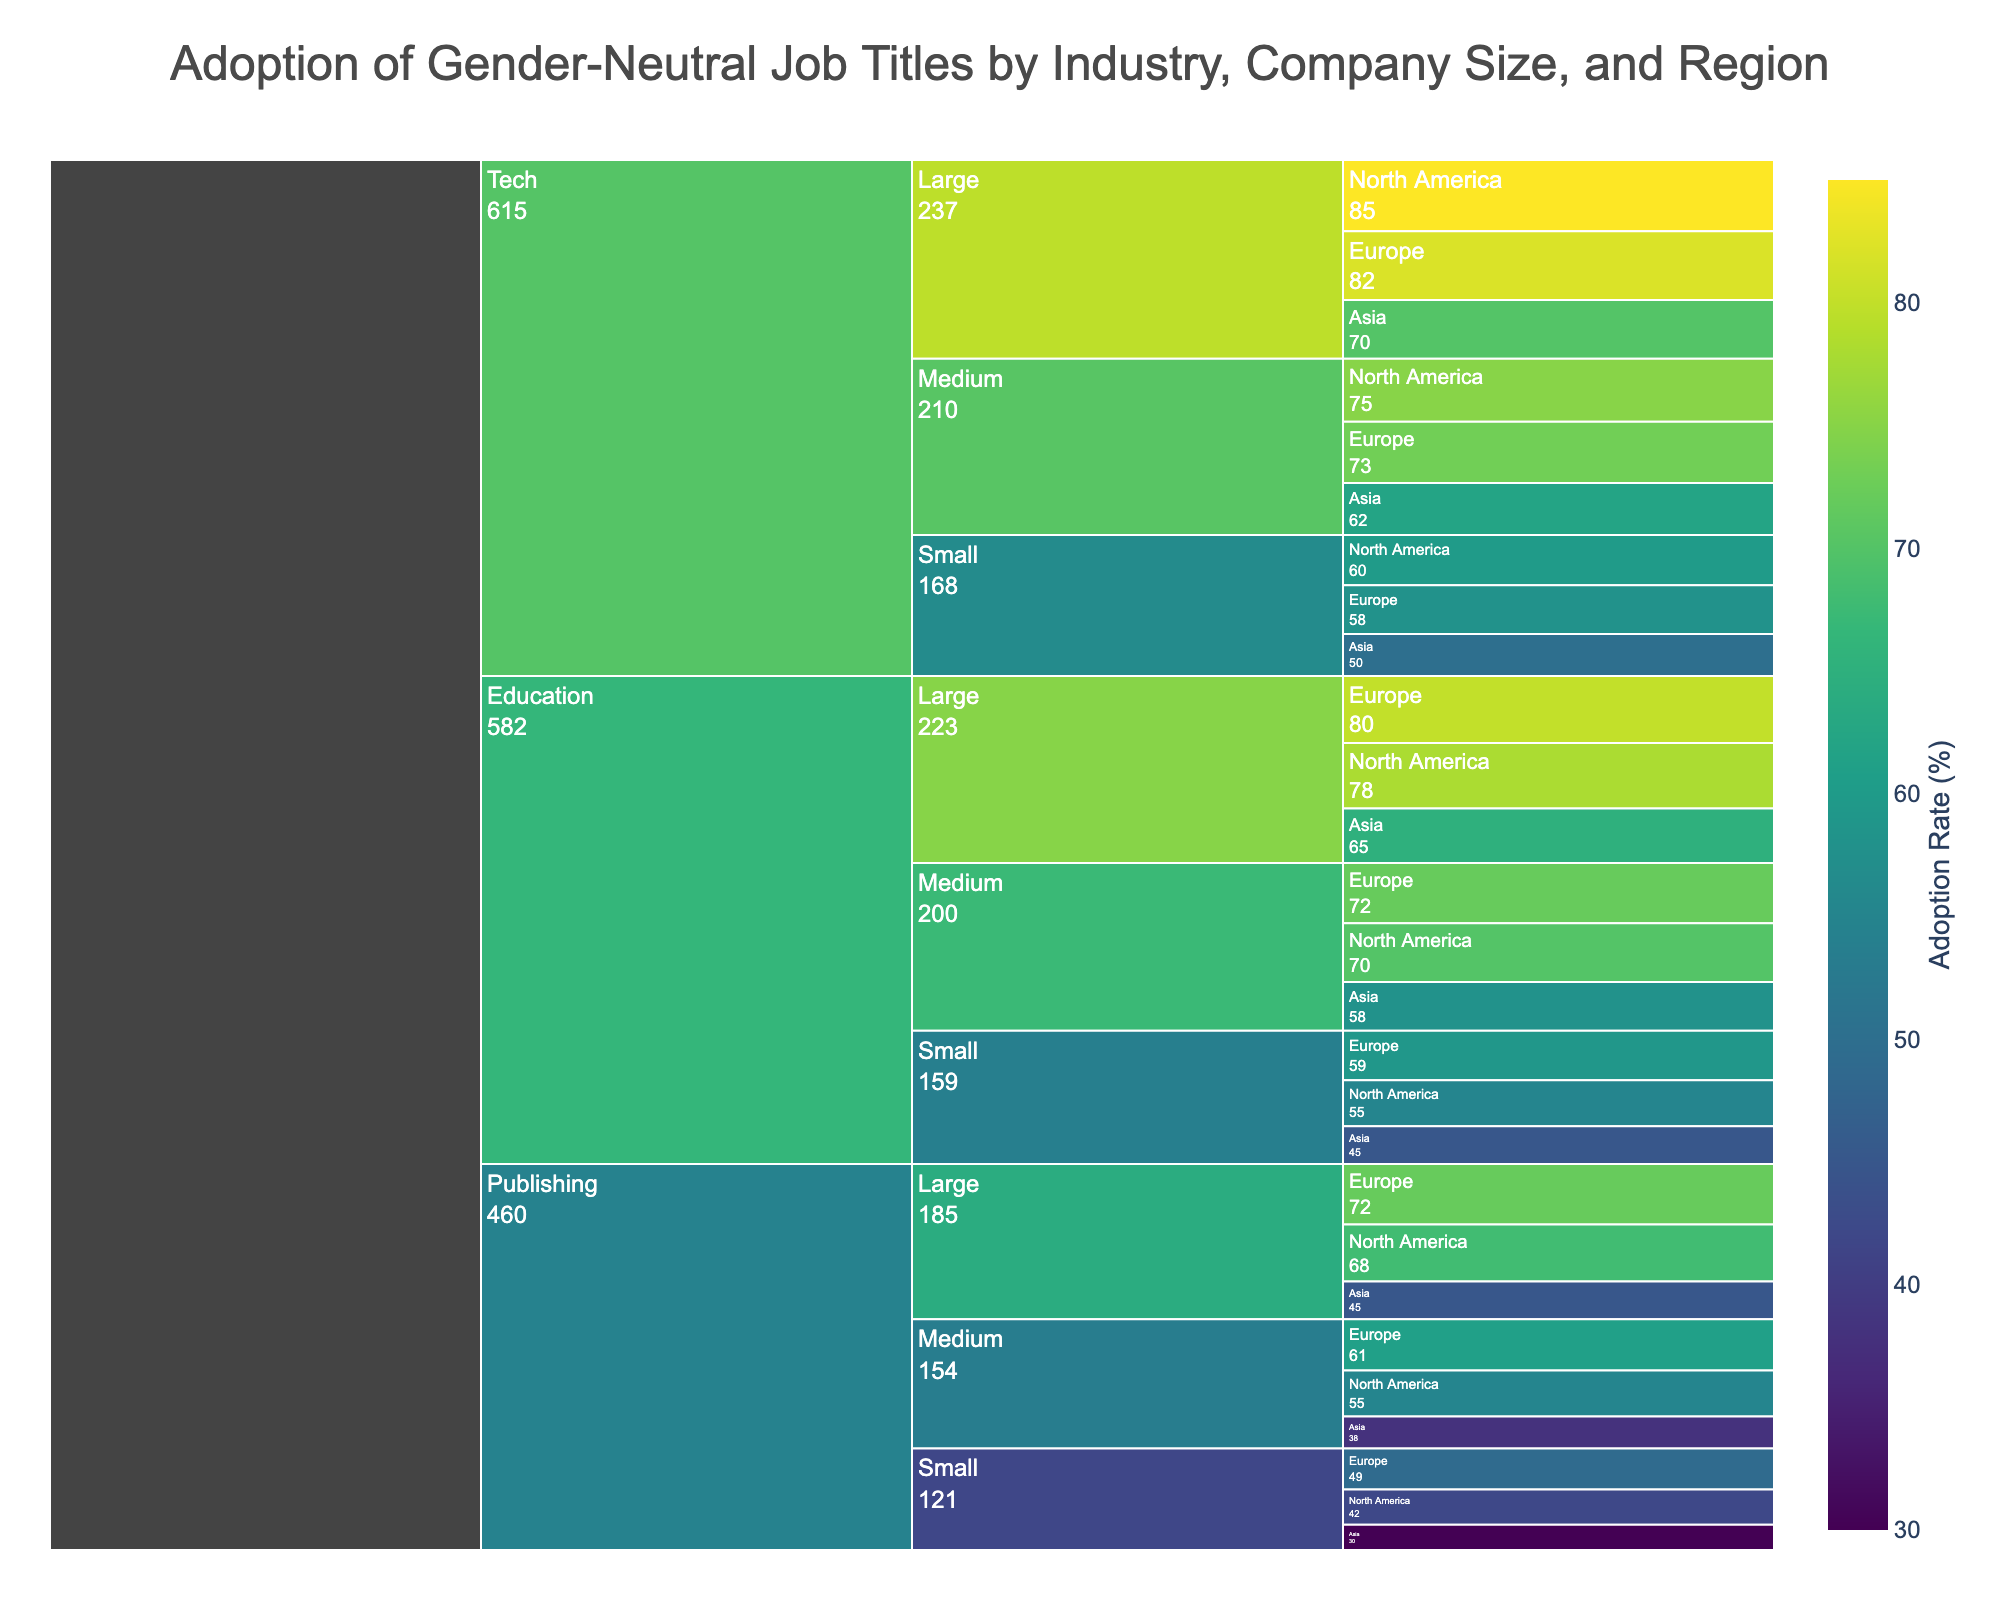What is the title of the figure? The title of the figure is displayed at the top of the Icicle Chart. It reads "Adoption of Gender-Neutral Job Titles by Industry, Company Size, and Region."
Answer: Adoption of Gender-Neutral Job Titles by Industry, Company Size, and Region Which industry has the highest adoption rate overall? To find the industry with the highest adoption rate, we need to compare the values given for different industries. Tech sector generally has higher adoption rates compared to Publishing and Education.
Answer: Tech What is the adoption rate for medium-sized tech companies in Asia? Locate the section for the Tech industry, then navigate to medium-sized companies and find the adoption rate for Asia.
Answer: 62% Which region shows the highest adoption rate for large publishing companies? In the Publishing industry section, look at large companies and compare the values for North America, Europe, and Asia. Europe has the highest adoption rate of 72%.
Answer: Europe What is the difference in adoption rates between small and large companies in the Education industry in North America? Find the adoption rates for small and large Educational companies in North America and subtract the smaller value from the larger one: 78% (large) - 55% (small).
Answer: 23% Which combination of industry, company size, and region has the lowest adoption rate? Scan the entire Icicle Chart to find the lowest adoption rate. Small Publishing companies in Asia have the lowest adoption rate of 30%.
Answer: Small Publishing companies in Asia How does the adoption rate compare between small-sized tech companies in North America and Europe? Compare the values for small tech companies in North America and Europe. North America has a value of 60%, while Europe has 58%, making North America's adoption rate slightly higher.
Answer: North America is higher by 2% What is the average adoption rate for medium-sized companies across all industries in Europe? Sum the adoption rates for medium-sized companies in Publishing, Tech, and Education in Europe and then divide by the number of industries: (61 + 73 + 72) / 3 = 68.67%.
Answer: 68.67% Which region has the most consistent adoption rates across different company sizes within the Tech industry? Examine the adoption rates for different company sizes within the Tech industry for North America, Europe, and Asia. North America has fairly consistent rates (Large: 85%, Medium: 75%, Small: 60%), compared to greater variability in other regions.
Answer: North America How does the adoption rate for medium-sized companies in the Publishing industry in North America compare to the same company size in Asia? Locate the adoption rates for medium-sized companies in the Publishing industry in North America and Asia and compare them. North America’s rate is 55%, while Asia's is 38%, so North America's adoption rate is higher.
Answer: North America is higher by 17% 